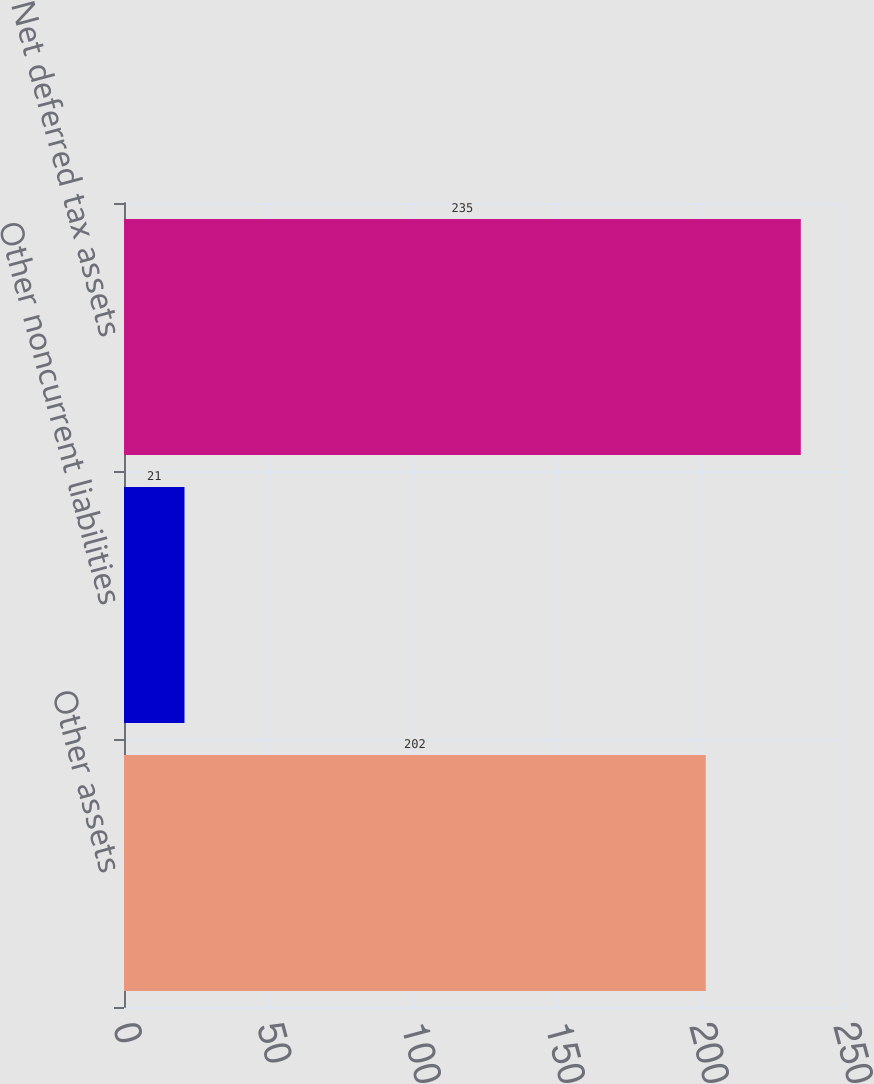Convert chart to OTSL. <chart><loc_0><loc_0><loc_500><loc_500><bar_chart><fcel>Other assets<fcel>Other noncurrent liabilities<fcel>Net deferred tax assets<nl><fcel>202<fcel>21<fcel>235<nl></chart> 